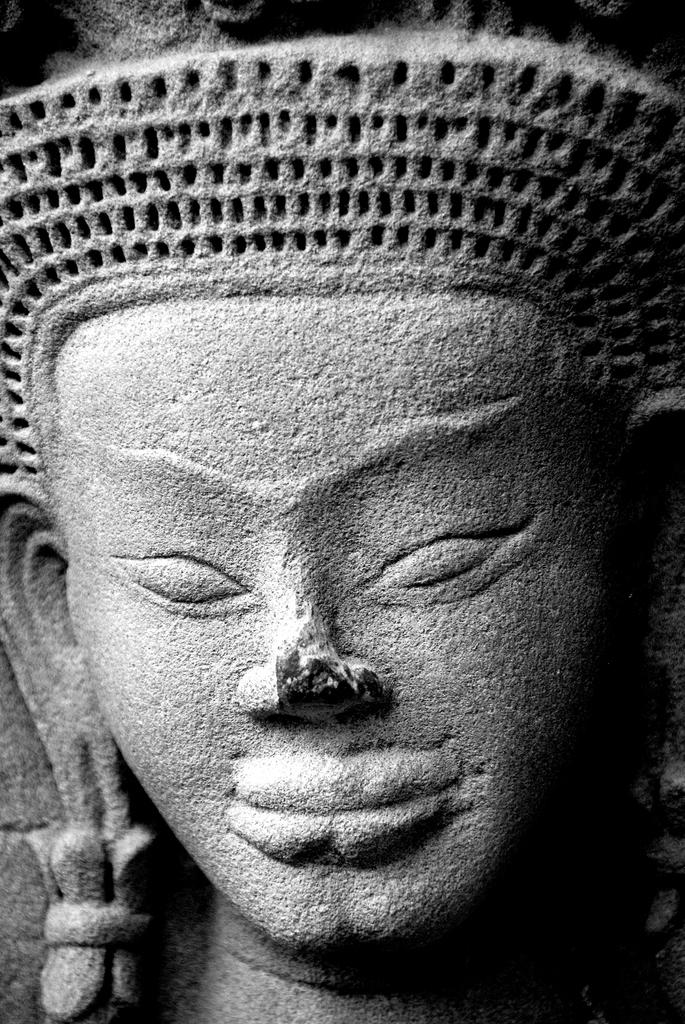What is the main subject of the image? There is a sculpture in the image. Can you describe the sculpture? The sculpture is shaped like a human face. What material is the sculpture made of? The sculpture is made up of stone. What type of fuel is used to power the sculpture in the image? There is no fuel present in the image, as the sculpture is made of stone and is not a functioning object. 